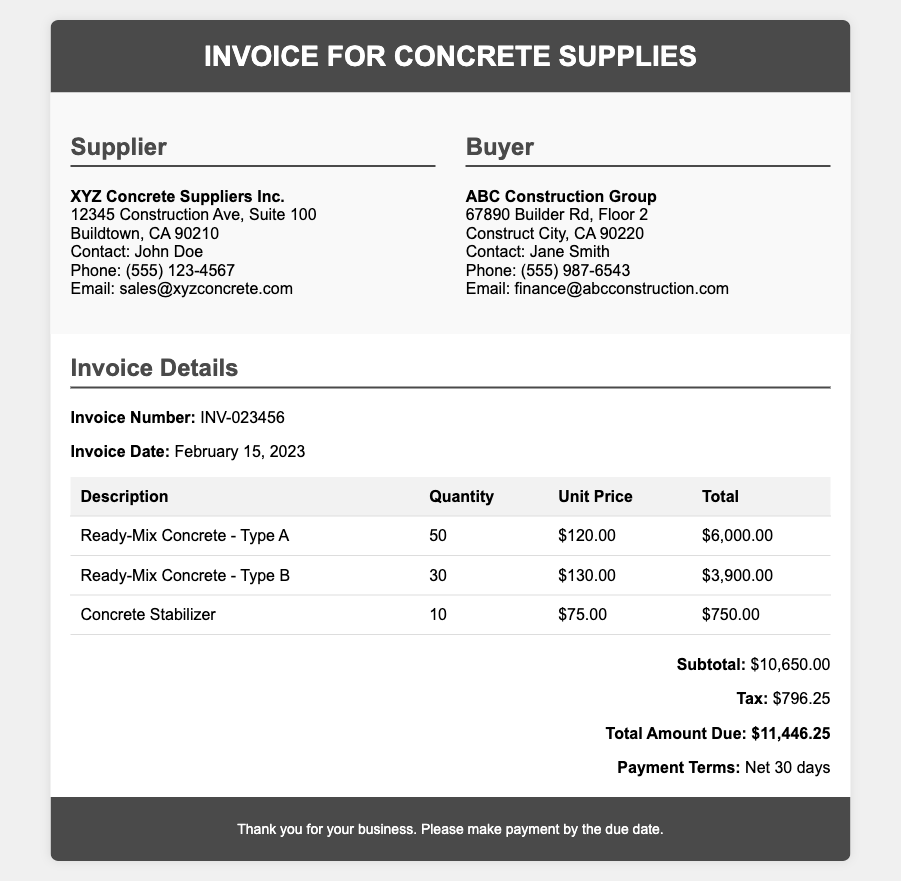What is the invoice number? The invoice number is listed in the document as INV-023456.
Answer: INV-023456 When was the invoice date? The invoice date is mentioned as February 15, 2023.
Answer: February 15, 2023 Who is the supplier? The supplier's name is presented as XYZ Concrete Suppliers Inc.
Answer: XYZ Concrete Suppliers Inc What is the total amount due? The total amount due is calculated at the end of the document and shown as $11,446.25.
Answer: $11,446.25 What is the quantity of Ready-Mix Concrete - Type A? The quantity for Ready-Mix Concrete - Type A is provided in the table as 50.
Answer: 50 How much is the unit price for Concrete Stabilizer? The unit price for Concrete Stabilizer is indicated in the table as $75.00.
Answer: $75.00 What are the payment terms? The document specifies the payment terms as Net 30 days.
Answer: Net 30 days What is the subtotal before tax? The subtotal before tax is shown as $10,650.00 in the total section.
Answer: $10,650.00 What is the tax amount? The tax amount is stated in the document as $796.25.
Answer: $796.25 